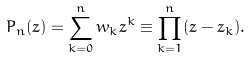<formula> <loc_0><loc_0><loc_500><loc_500>P _ { n } ( z ) = \sum _ { k = 0 } ^ { n } w _ { k } z ^ { k } \equiv \prod _ { k = 1 } ^ { n } ( z - z _ { k } ) .</formula> 